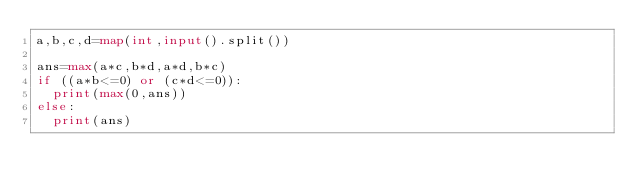<code> <loc_0><loc_0><loc_500><loc_500><_Python_>a,b,c,d=map(int,input().split())
 
ans=max(a*c,b*d,a*d,b*c)
if ((a*b<=0) or (c*d<=0)):
  print(max(0,ans))
else:
  print(ans)</code> 